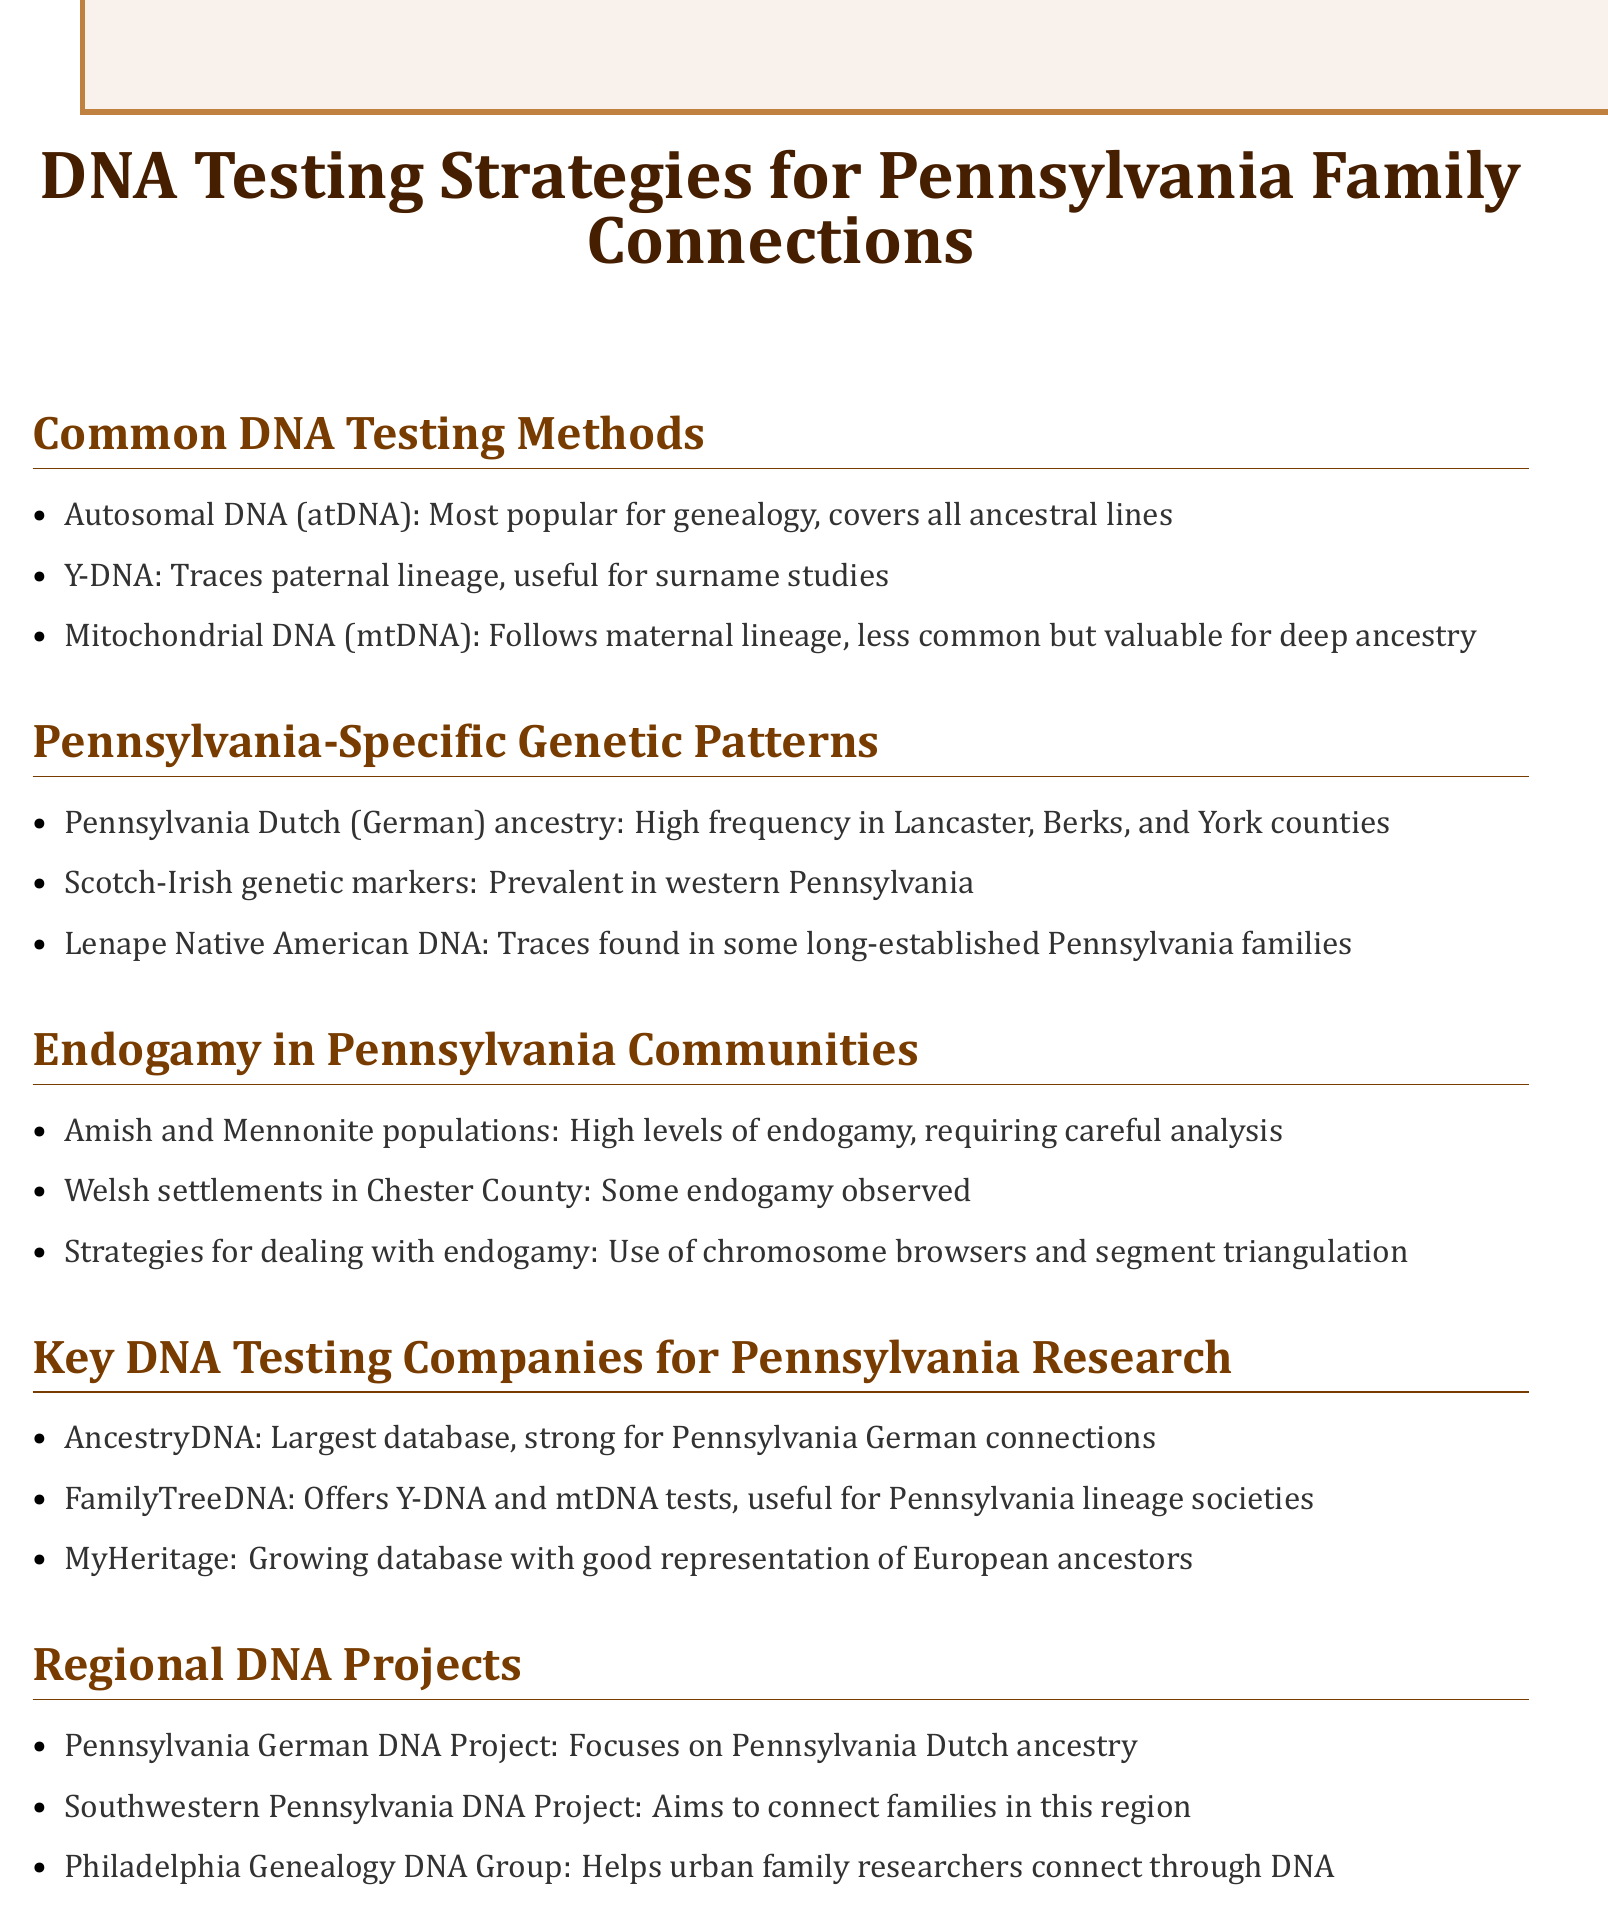what is the most common DNA testing method mentioned? The document emphasizes that autosomal DNA testing is the most popular choice for genealogy purposes.
Answer: autosomal DNA which counties have high Pennsylvania Dutch ancestry? The document lists Lancaster, Berks, and York counties as areas with a high frequency of Pennsylvania Dutch ancestry.
Answer: Lancaster, Berks, and York what type of genetic markers are prevalent in western Pennsylvania? The document states that Scotch-Irish genetic markers are common in western Pennsylvania.
Answer: Scotch-Irish what strategies are suggested for dealing with endogamy? The document recommends using chromosome browsers and segment triangulation as strategies for analyzing endogamy in communities.
Answer: chromosome browsers and segment triangulation which DNA testing company has the largest database for Pennsylvania research? The document identifies AncestryDNA as having the largest database, especially beneficial for Pennsylvania German connections.
Answer: AncestryDNA what project focuses on Pennsylvania Dutch ancestry? The document lists the Pennsylvania German DNA Project as focusing on Pennsylvania Dutch ancestry.
Answer: Pennsylvania German DNA Project how many types of DNA testing methods are listed in the document? The document details three types of DNA testing methods available for genealogical research.
Answer: three which community in Pennsylvania is noted for high endogamy levels? The document highlights the Amish and Mennonite populations as having high levels of endogamy.
Answer: Amish and Mennonite which regional DNA project aims to connect families in southwestern Pennsylvania? The document mentions the Southwestern Pennsylvania DNA Project as targeting familial connections in that area.
Answer: Southwestern Pennsylvania DNA Project 